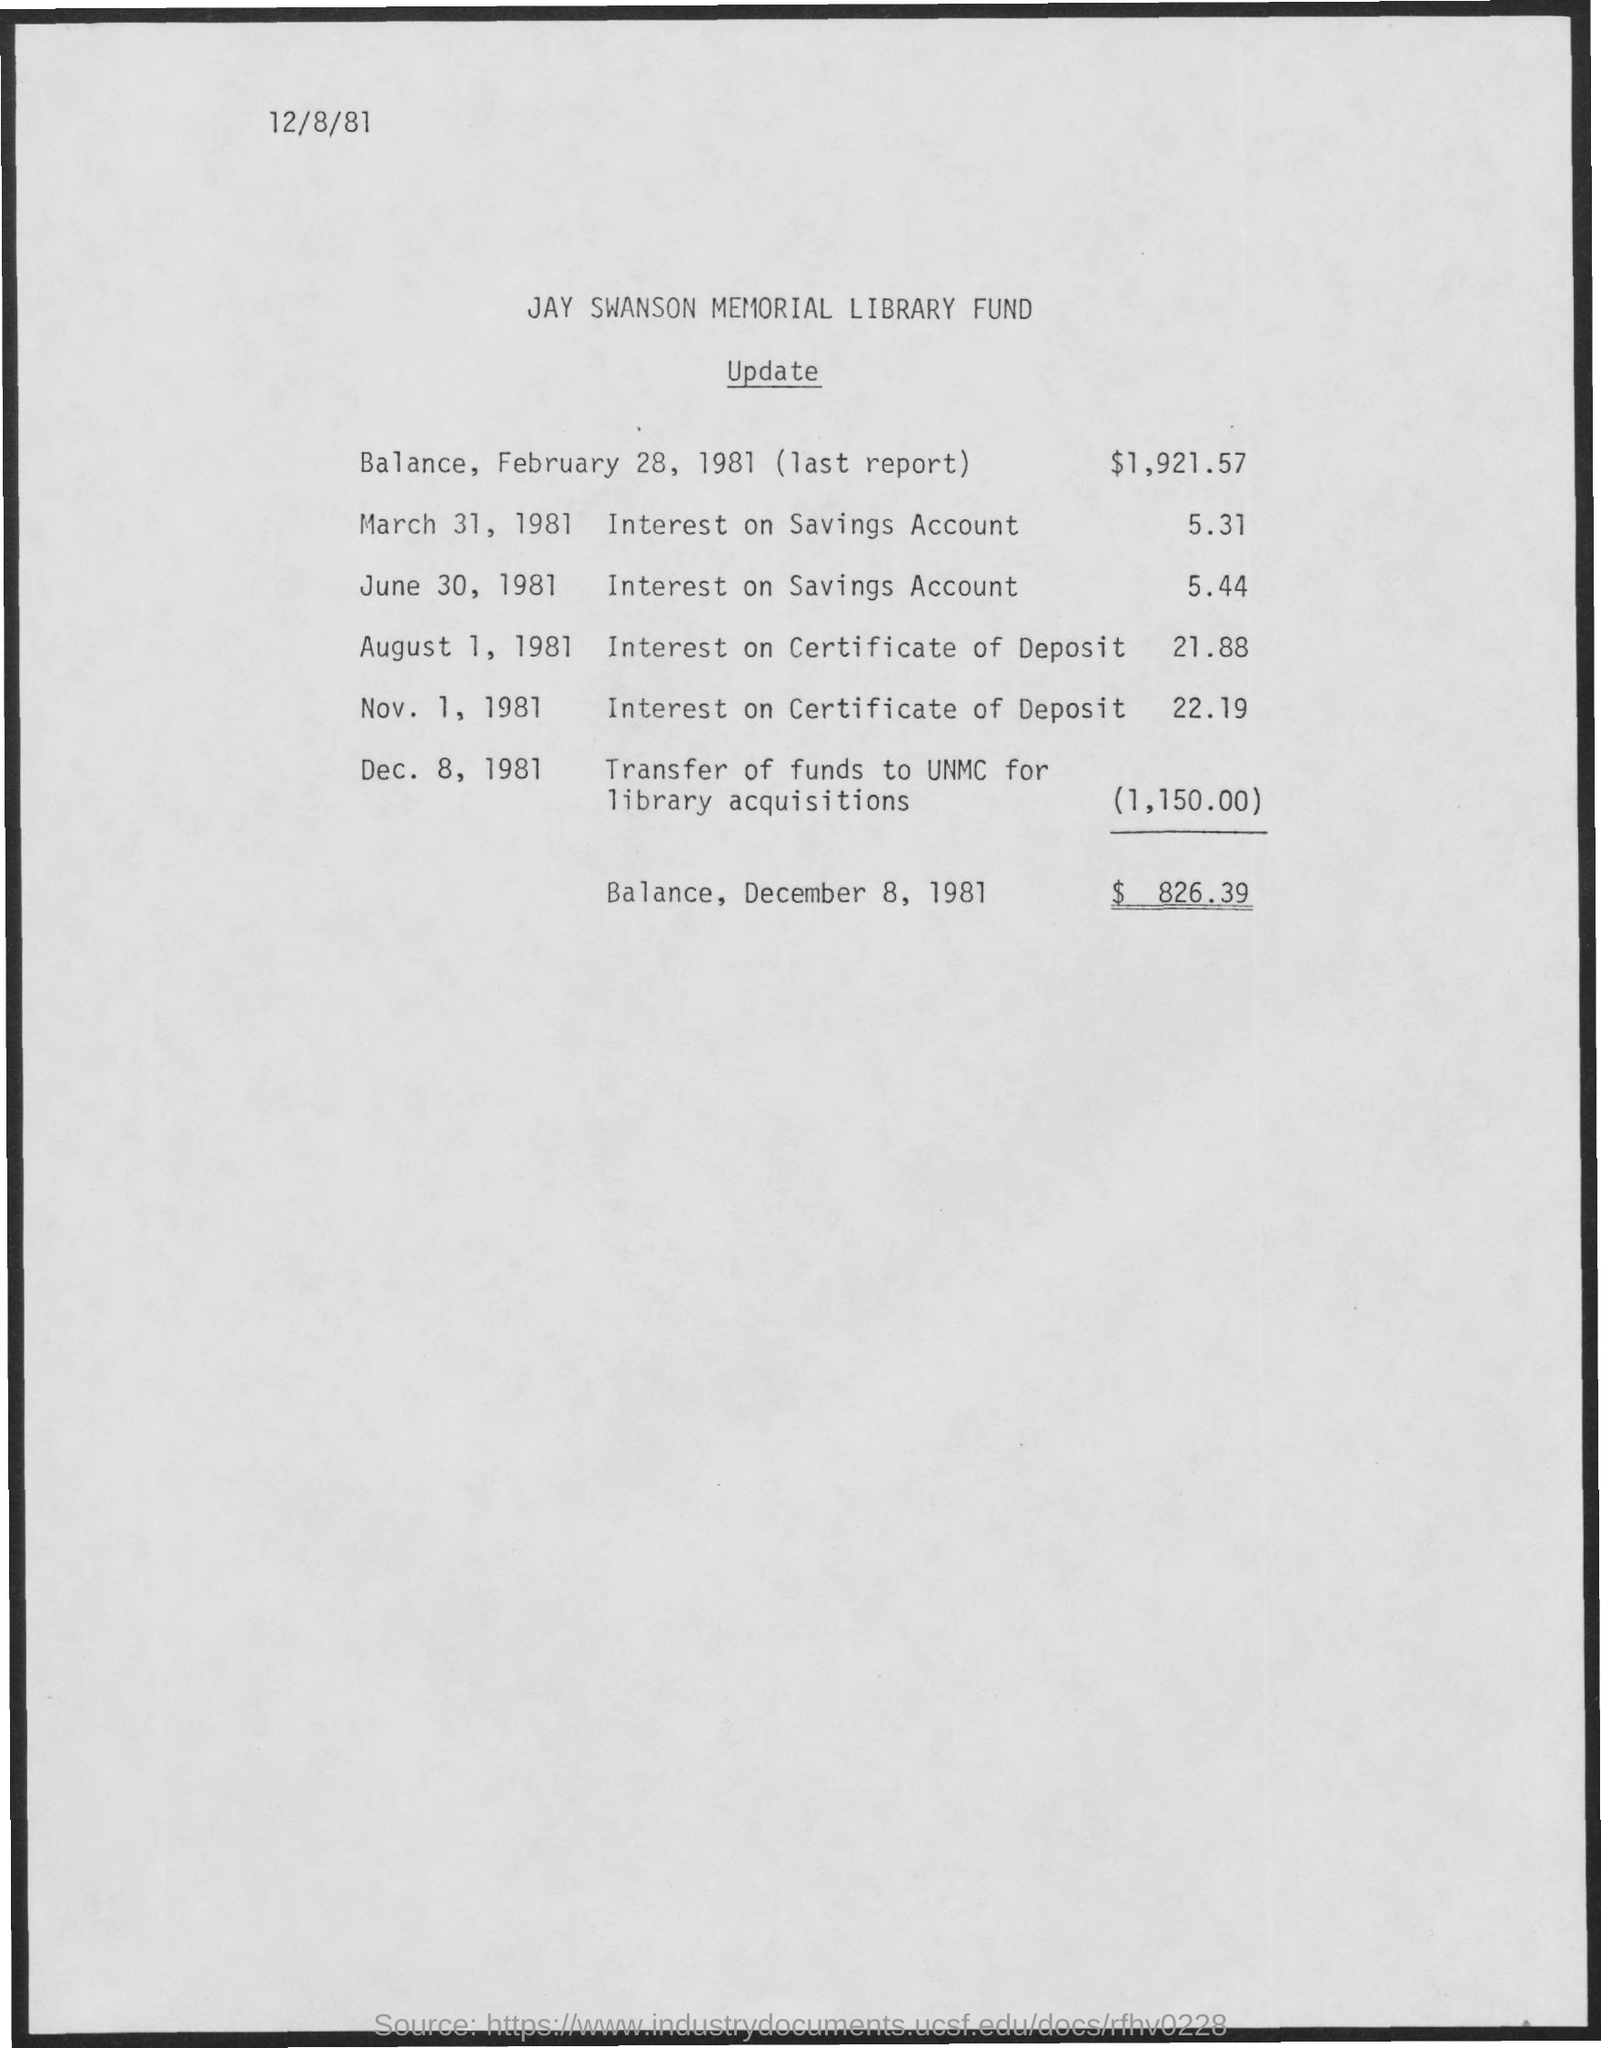What is date of document?
Make the answer very short. 12/8/81. What is balance on December 8, 1981?
Your answer should be very brief. $826.39. What is balance on February 28, 1981?
Ensure brevity in your answer.  1921.57. 